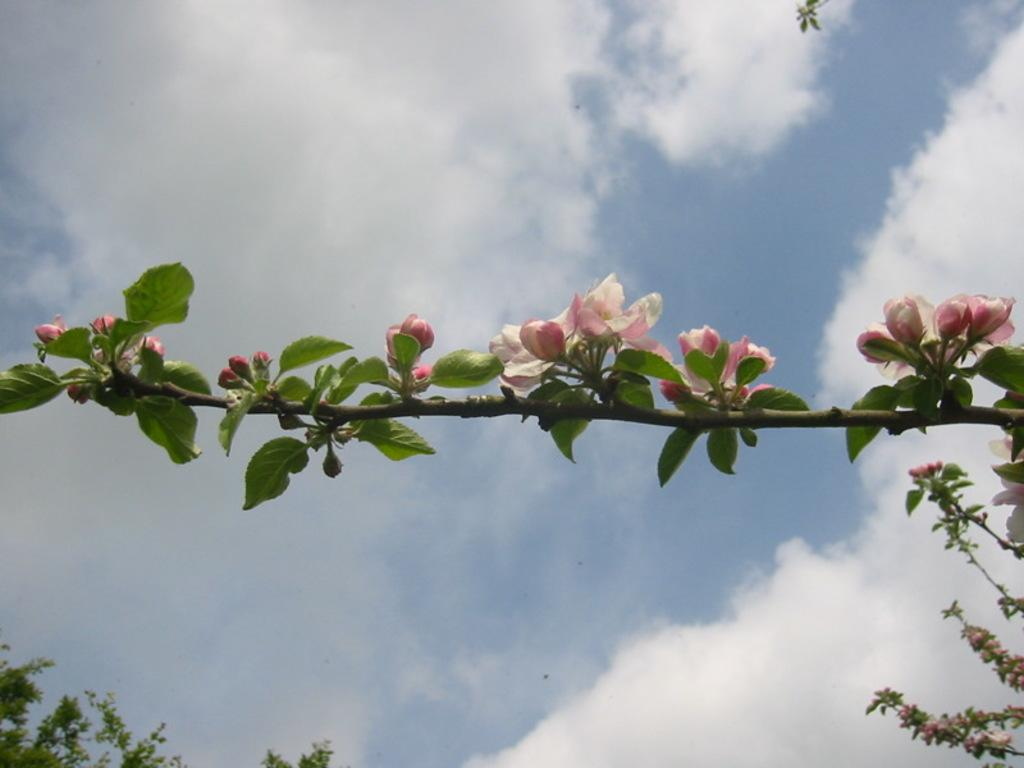What is the main subject in the center of the image? There is a flower on a plant in the center of the image. How would you describe the sky in the image? The sky is cloudy in the image. Where are the leaves located in the image? The leaves are on the bottom left of the image. How many girls are present in the image? There is no girl present in the image; it features a flower on a plant, leaves, and a cloudy sky. What class is the flower attending in the image? There is no class or educational context in the image; it simply shows a flower on a plant, leaves, and a cloudy sky. 